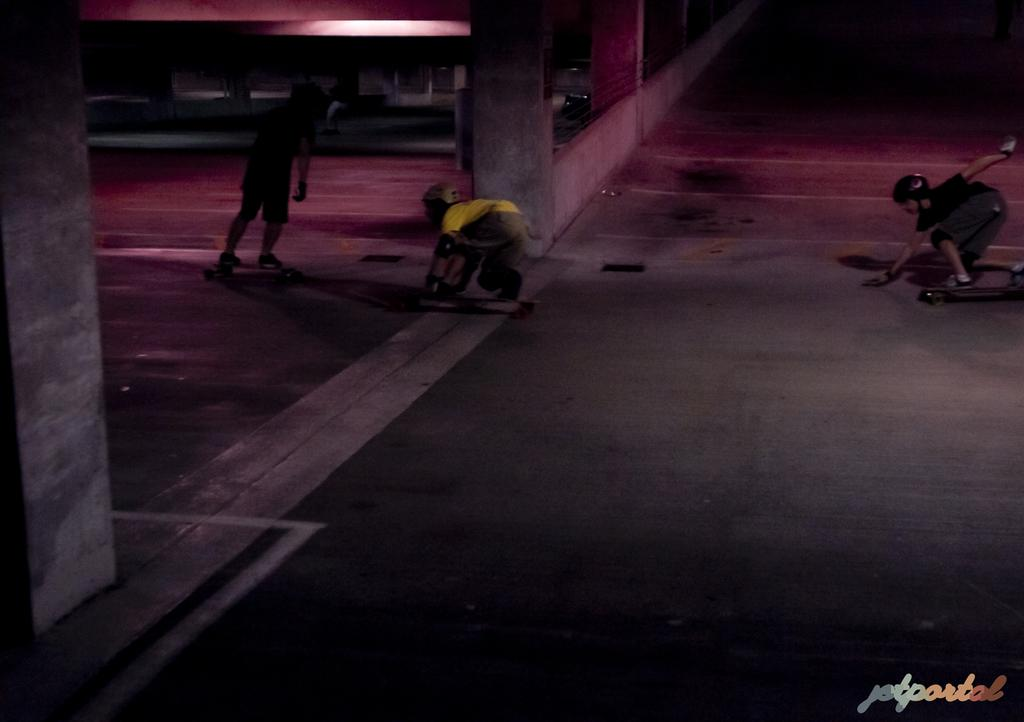What is the main subject of the image? The main subject of the image is the boys. What are the boys doing in the image? The boys are standing on a skateboard in the image. What other objects can be seen in the image? There is a pillar and a light in the image. What decision did the band make during the operation in the image? There is no band or operation present in the image; it features boys standing on a skateboard with a pillar and a light in the background. 